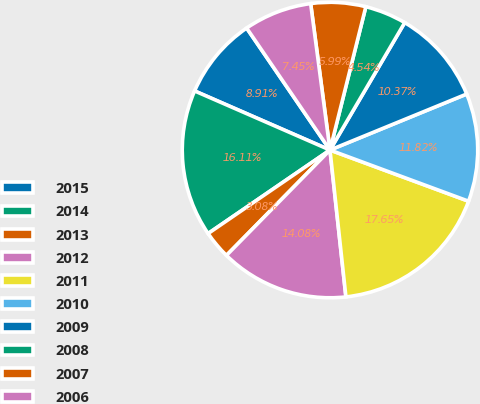Convert chart. <chart><loc_0><loc_0><loc_500><loc_500><pie_chart><fcel>2015<fcel>2014<fcel>2013<fcel>2012<fcel>2011<fcel>2010<fcel>2009<fcel>2008<fcel>2007<fcel>2006<nl><fcel>8.91%<fcel>16.11%<fcel>3.08%<fcel>14.08%<fcel>17.65%<fcel>11.82%<fcel>10.37%<fcel>4.54%<fcel>5.99%<fcel>7.45%<nl></chart> 